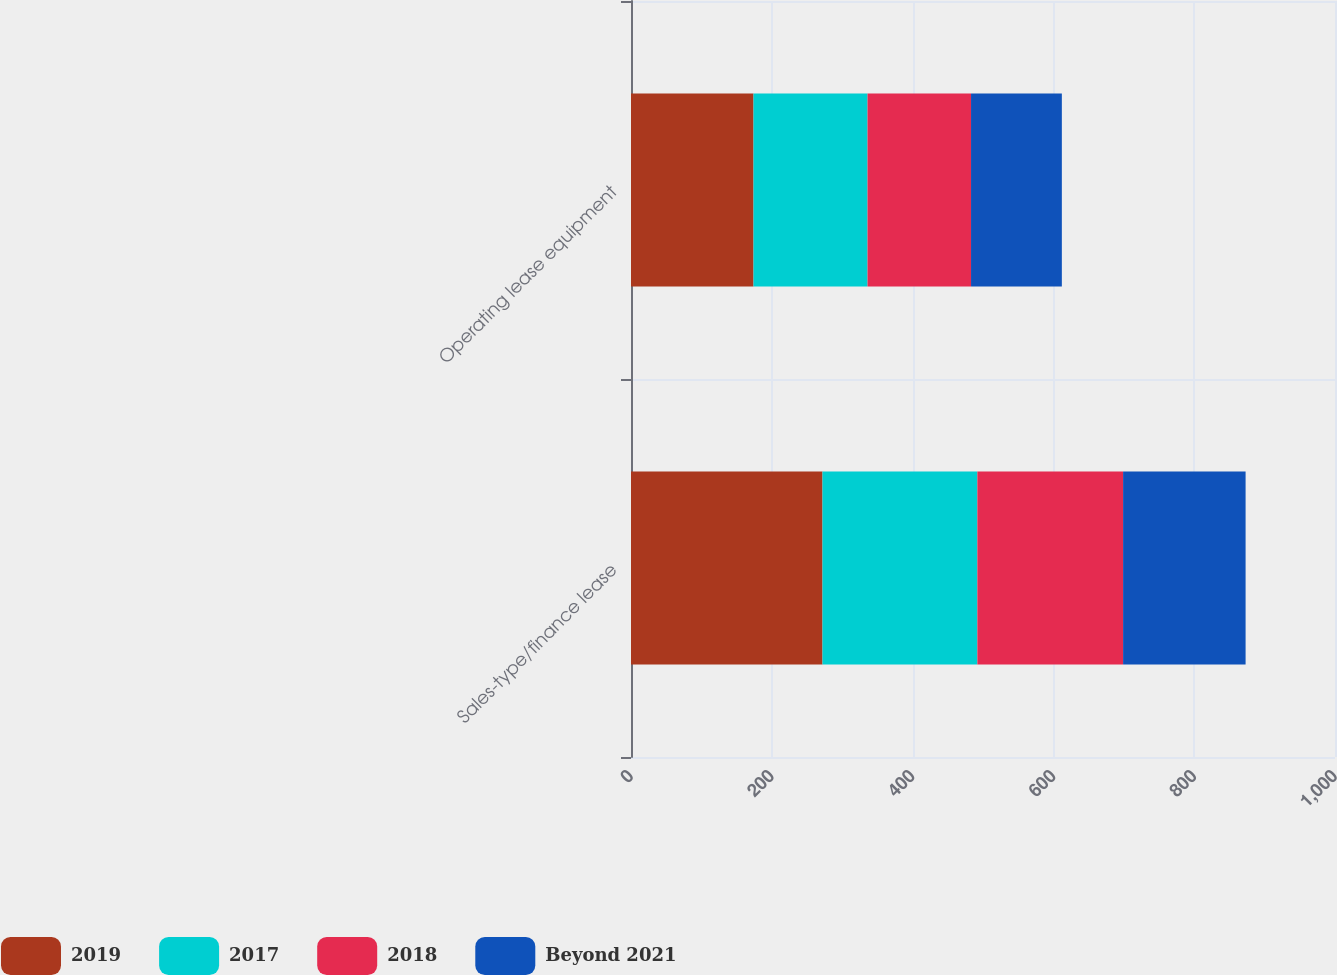<chart> <loc_0><loc_0><loc_500><loc_500><stacked_bar_chart><ecel><fcel>Sales-type/finance lease<fcel>Operating lease equipment<nl><fcel>2019<fcel>272<fcel>174<nl><fcel>2017<fcel>220<fcel>162<nl><fcel>2018<fcel>207<fcel>147<nl><fcel>Beyond 2021<fcel>174<fcel>129<nl></chart> 